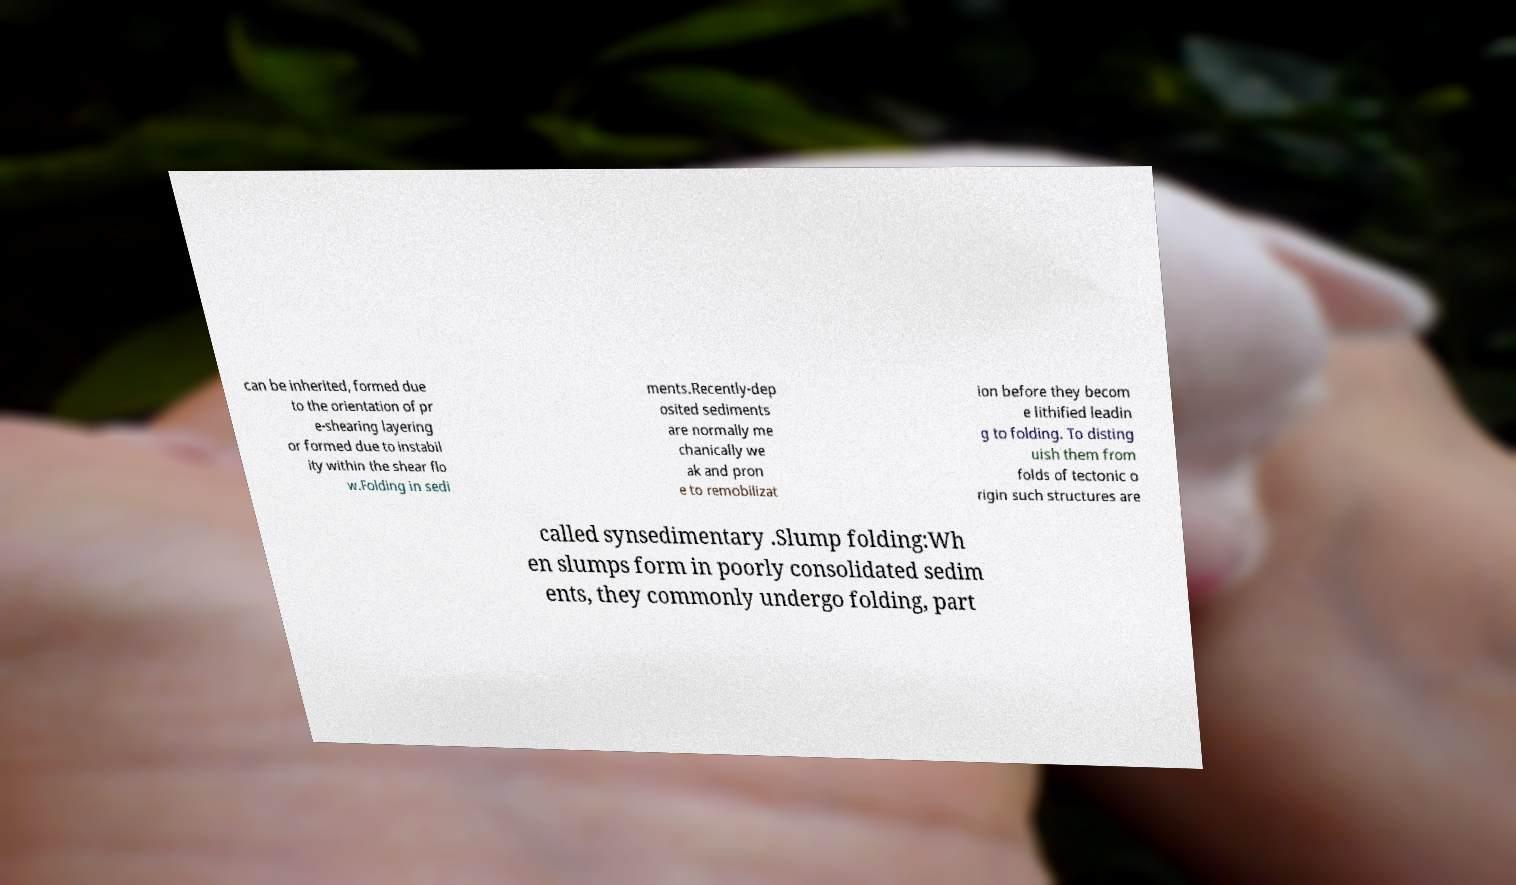What messages or text are displayed in this image? I need them in a readable, typed format. can be inherited, formed due to the orientation of pr e-shearing layering or formed due to instabil ity within the shear flo w.Folding in sedi ments.Recently-dep osited sediments are normally me chanically we ak and pron e to remobilizat ion before they becom e lithified leadin g to folding. To disting uish them from folds of tectonic o rigin such structures are called synsedimentary .Slump folding:Wh en slumps form in poorly consolidated sedim ents, they commonly undergo folding, part 